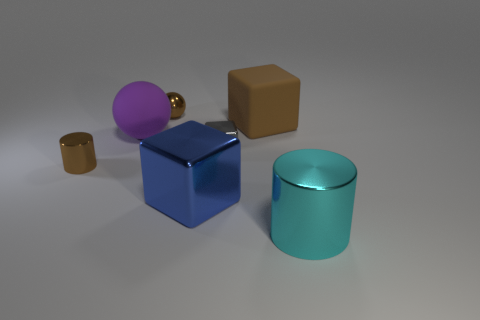There is another cube that is the same size as the brown matte cube; what is its material?
Offer a very short reply. Metal. There is a metallic cube that is to the right of the big metal object that is behind the large metallic object in front of the large blue block; how big is it?
Keep it short and to the point. Small. There is a tiny brown shiny cylinder to the left of the purple rubber object; is there a large thing behind it?
Ensure brevity in your answer.  Yes. There is a blue object; is it the same shape as the tiny brown metal object that is in front of the brown rubber object?
Make the answer very short. No. There is a cylinder that is to the left of the large brown object; what color is it?
Your response must be concise. Brown. There is a cylinder right of the cylinder that is behind the blue metal thing; how big is it?
Your response must be concise. Large. There is a large brown object right of the gray metallic object; is it the same shape as the gray shiny object?
Your answer should be compact. Yes. There is a brown thing that is the same shape as the large cyan metallic object; what is its material?
Offer a terse response. Metal. How many things are either balls that are in front of the tiny sphere or objects behind the brown metallic cylinder?
Your response must be concise. 4. Does the large matte block have the same color as the shiny cylinder to the left of the big brown rubber cube?
Ensure brevity in your answer.  Yes. 